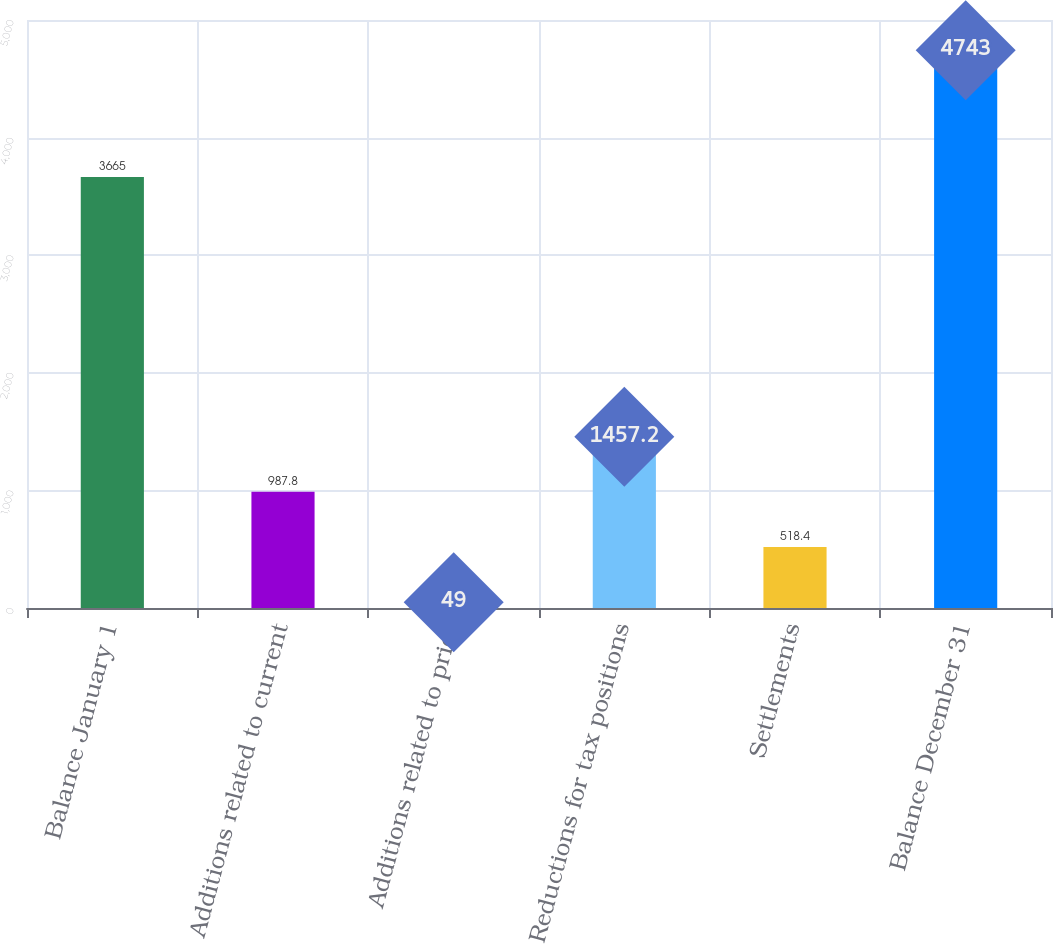Convert chart. <chart><loc_0><loc_0><loc_500><loc_500><bar_chart><fcel>Balance January 1<fcel>Additions related to current<fcel>Additions related to prior<fcel>Reductions for tax positions<fcel>Settlements<fcel>Balance December 31<nl><fcel>3665<fcel>987.8<fcel>49<fcel>1457.2<fcel>518.4<fcel>4743<nl></chart> 